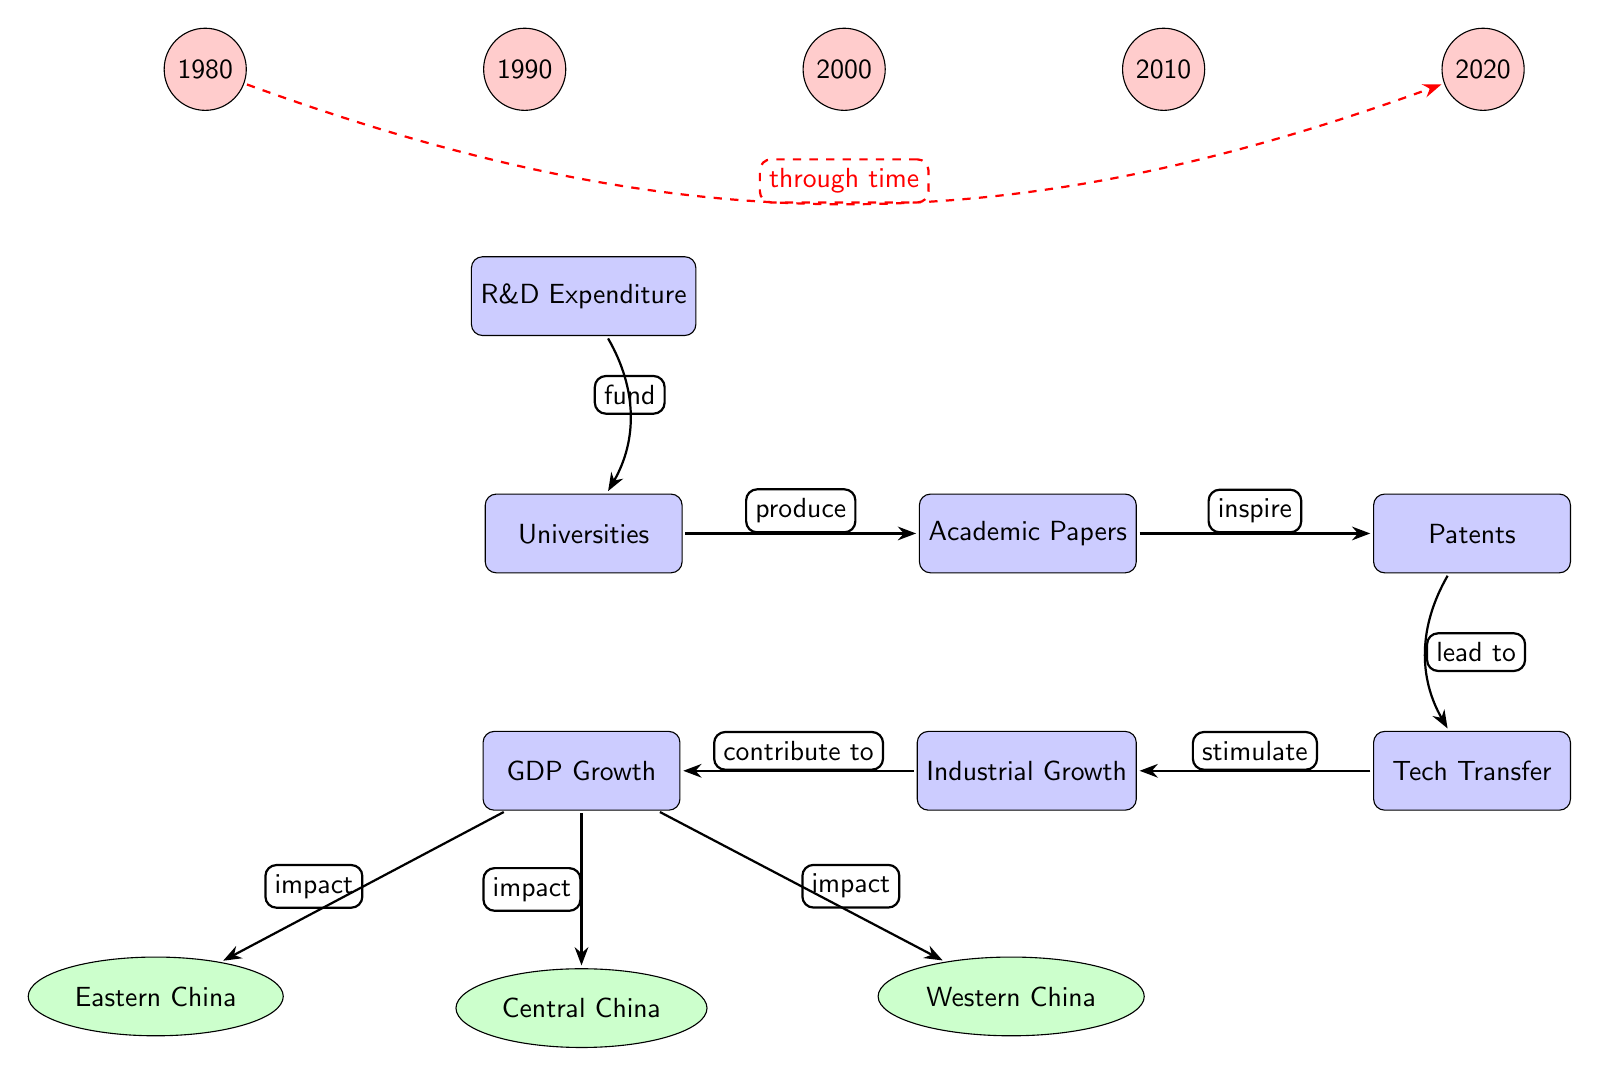What is the starting point of the flow in the diagram? The flow in the diagram begins with the node labeled "R&D Expenditure." This is the first process in the diagram where resources are allocated for research and development.
Answer: R&D Expenditure How many regions are represented in the diagram? The diagram includes three regions: Eastern China, Central China, and Western China. These regions are shown below the GDP Growth node, indicating their impact from economic development.
Answer: 3 What characterizes the relationship between "Academic Papers" and "Patents"? The relationship between "Academic Papers" and "Patents" is characterized by the arrow labeled "inspire," indicating that the production of academic papers leads to the creation of patents.
Answer: Inspire What is the final outcome indicated in the diagram? The final outcome represented in the diagram is "GDP Growth." This node is the last in the flow, showing the effect of previous processes on economic development.
Answer: GDP Growth Which region is shown to have the impact from "GDP Growth"? The regions impacted by "GDP Growth" are Eastern China, Central China, and Western China. The arrows from GDP point towards each of these regions, illustrating that they all experience the economic effects.
Answer: Eastern China, Central China, Western China What does "Tech Transfer" lead to in the diagram? "Tech Transfer" leads to "Industrial Growth," as indicated by the arrow labeled "stimulate," showing how technological advancements contribute to the growth of industries.
Answer: Industrial Growth Which year marks the beginning of the time series represented in the diagram? The year that marks the beginning of the time series in the diagram is 1980, indicated by the node labeled "1980" at the top left of the diagram.
Answer: 1980 How does the diagram depict the influence of research over time? The diagram depicts the influence of research over time through a dashed red arrow that extends from 1980 to 2020, illustrating a continuous process of academic research affecting economic development across the years.
Answer: Through time 